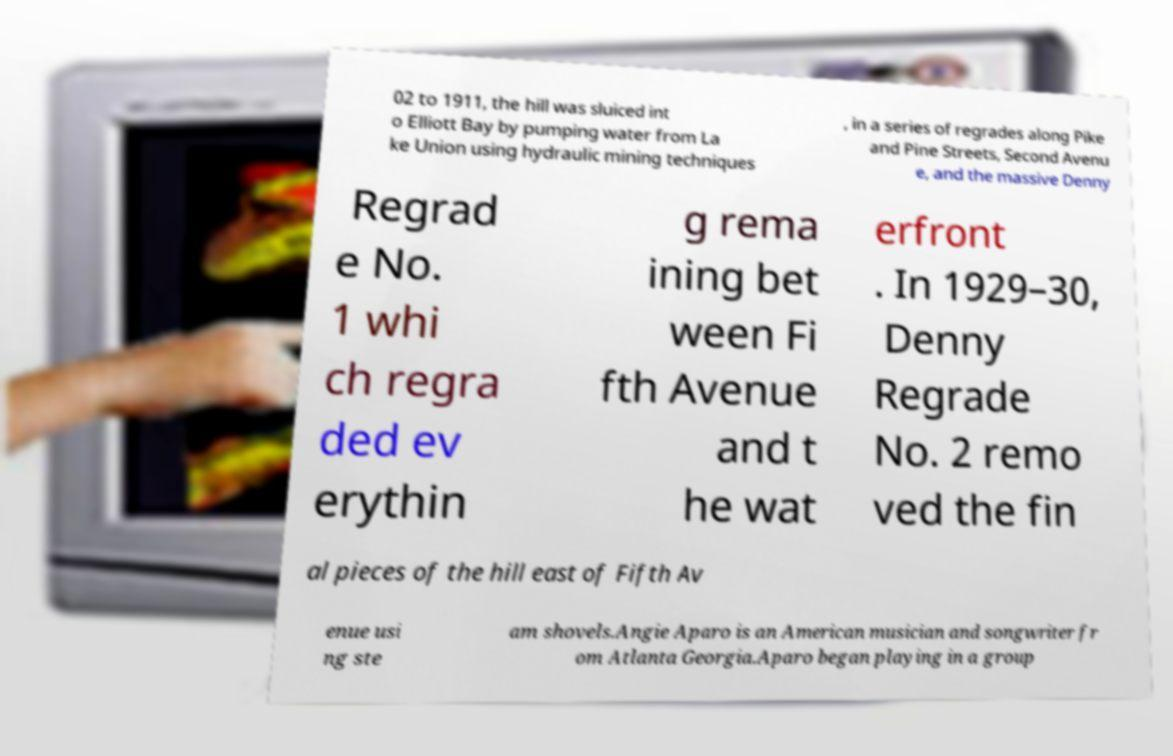What messages or text are displayed in this image? I need them in a readable, typed format. 02 to 1911, the hill was sluiced int o Elliott Bay by pumping water from La ke Union using hydraulic mining techniques , in a series of regrades along Pike and Pine Streets, Second Avenu e, and the massive Denny Regrad e No. 1 whi ch regra ded ev erythin g rema ining bet ween Fi fth Avenue and t he wat erfront . In 1929–30, Denny Regrade No. 2 remo ved the fin al pieces of the hill east of Fifth Av enue usi ng ste am shovels.Angie Aparo is an American musician and songwriter fr om Atlanta Georgia.Aparo began playing in a group 